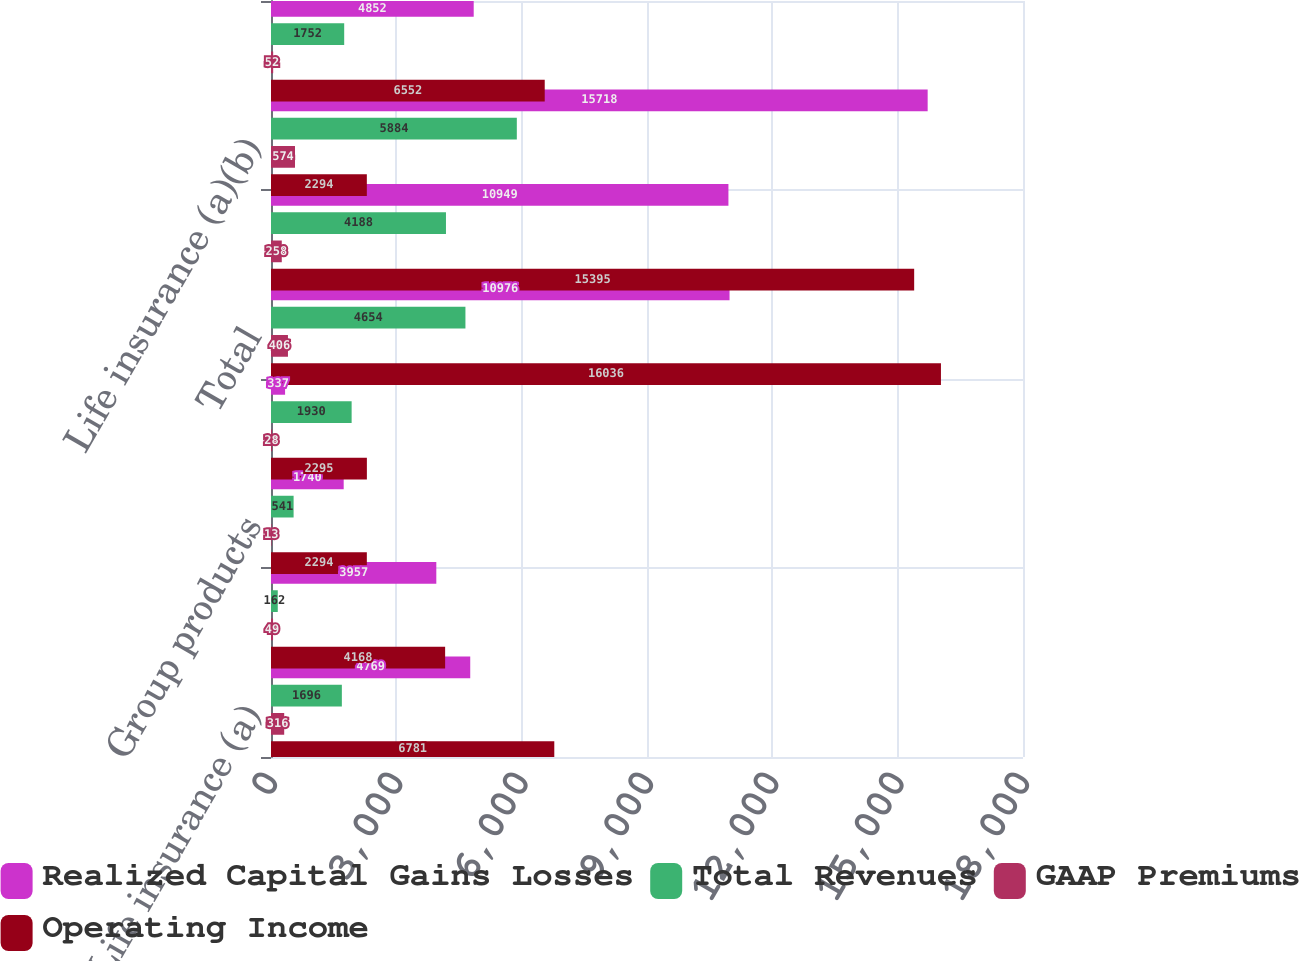<chart> <loc_0><loc_0><loc_500><loc_500><stacked_bar_chart><ecel><fcel>Life insurance (a)<fcel>Personal accident<fcel>Group products<fcel>Individual fixed annuities<fcel>Total<fcel>Life insurance (b)<fcel>Life insurance (a)(b)<fcel>Life insurance<nl><fcel>Realized Capital Gains Losses<fcel>4769<fcel>3957<fcel>1740<fcel>337<fcel>10976<fcel>10949<fcel>15718<fcel>4852<nl><fcel>Total Revenues<fcel>1696<fcel>162<fcel>541<fcel>1930<fcel>4654<fcel>4188<fcel>5884<fcel>1752<nl><fcel>GAAP Premiums<fcel>316<fcel>49<fcel>13<fcel>28<fcel>406<fcel>258<fcel>574<fcel>52<nl><fcel>Operating Income<fcel>6781<fcel>4168<fcel>2294<fcel>2295<fcel>16036<fcel>15395<fcel>2294<fcel>6552<nl></chart> 